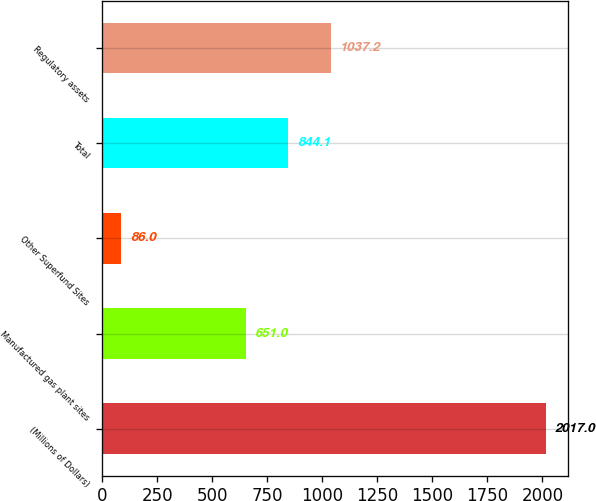Convert chart. <chart><loc_0><loc_0><loc_500><loc_500><bar_chart><fcel>(Millions of Dollars)<fcel>Manufactured gas plant sites<fcel>Other Superfund Sites<fcel>Total<fcel>Regulatory assets<nl><fcel>2017<fcel>651<fcel>86<fcel>844.1<fcel>1037.2<nl></chart> 